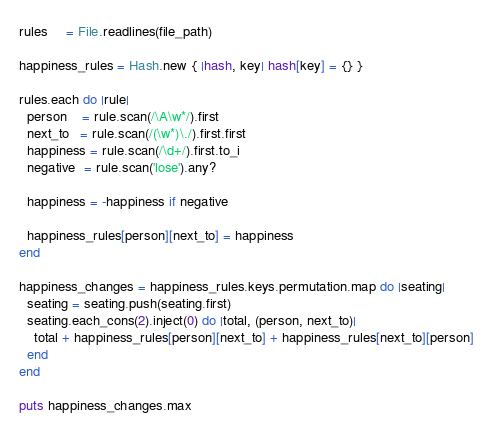Convert code to text. <code><loc_0><loc_0><loc_500><loc_500><_Ruby_>rules     = File.readlines(file_path)

happiness_rules = Hash.new { |hash, key| hash[key] = {} }

rules.each do |rule|
  person    = rule.scan(/\A\w*/).first
  next_to   = rule.scan(/(\w*)\./).first.first
  happiness = rule.scan(/\d+/).first.to_i
  negative  = rule.scan('lose').any?

  happiness = -happiness if negative

  happiness_rules[person][next_to] = happiness
end

happiness_changes = happiness_rules.keys.permutation.map do |seating|
  seating = seating.push(seating.first)
  seating.each_cons(2).inject(0) do |total, (person, next_to)|
    total + happiness_rules[person][next_to] + happiness_rules[next_to][person]
  end
end

puts happiness_changes.max
</code> 